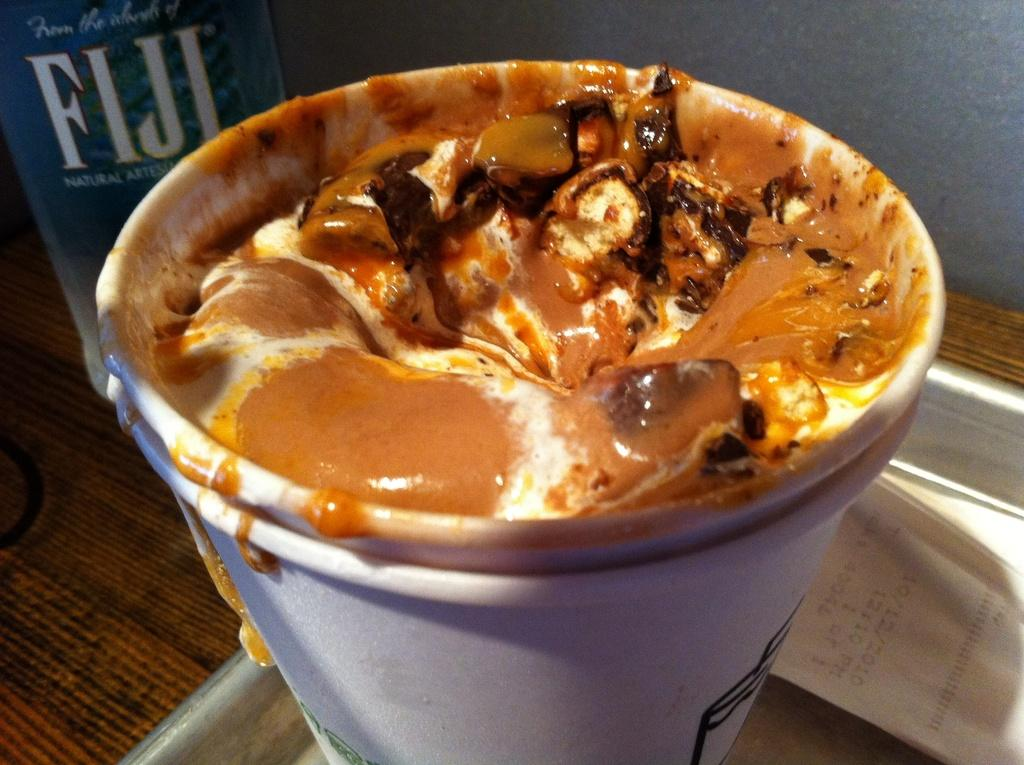What is in the cups that are visible in the image? There is coffee in cups in the image. How are the cups arranged in the image? The cups are in a tray. What is on the right side of the image? There is a bill paper on the right side of the image. What is on the left side of the image? There is a water bottle on the left side of the image. Where are the tray and water bottle located in the image? The tray and water bottle are on a table. How does the dirt contribute to the image? There is no dirt present in the image. 